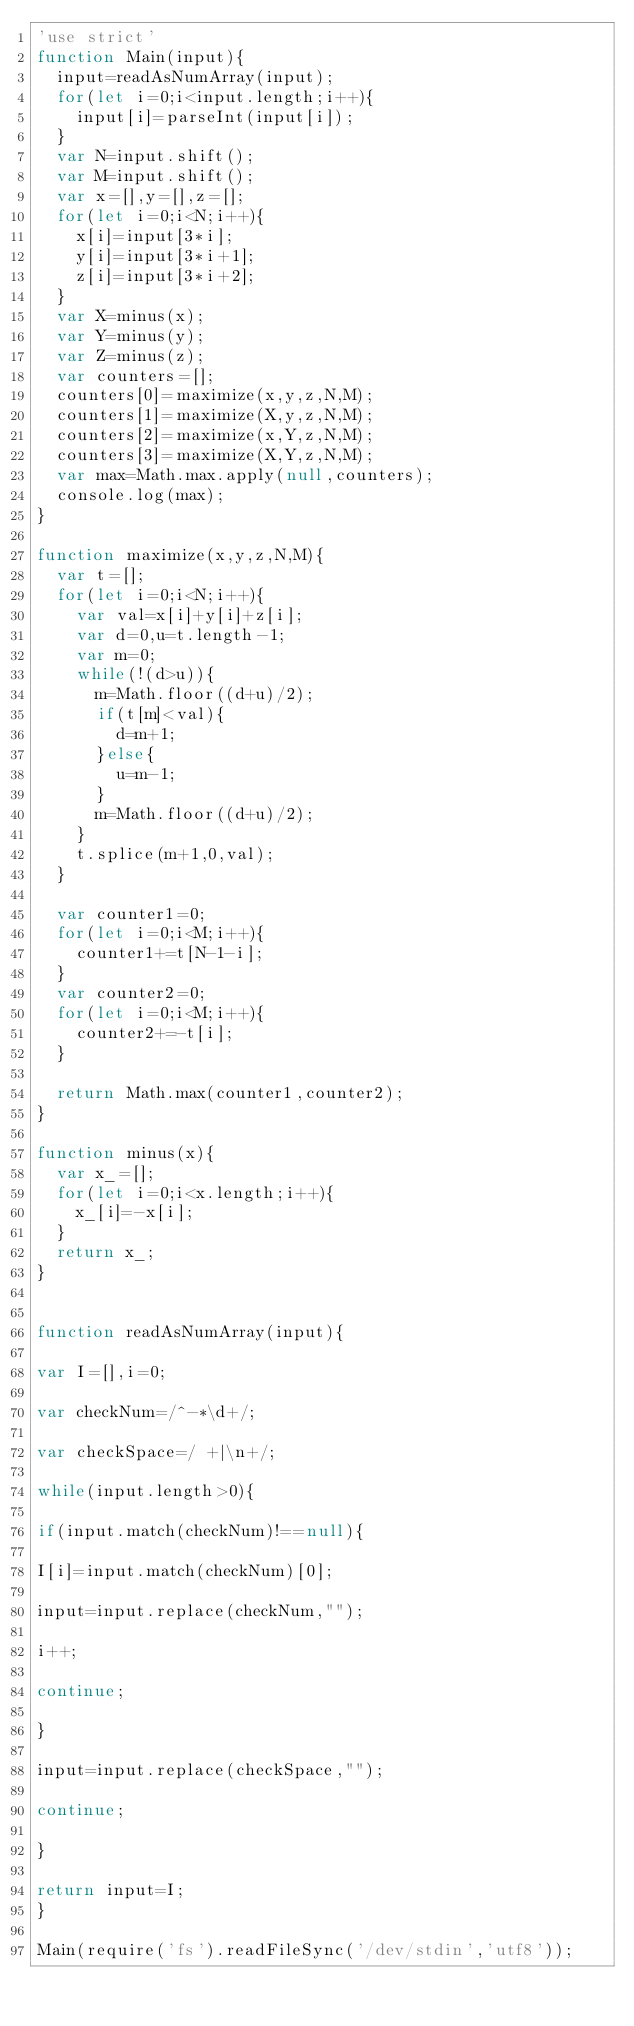<code> <loc_0><loc_0><loc_500><loc_500><_JavaScript_>'use strict'
function Main(input){
  input=readAsNumArray(input);
  for(let i=0;i<input.length;i++){
    input[i]=parseInt(input[i]);
  }
  var N=input.shift();
  var M=input.shift();
  var x=[],y=[],z=[];
  for(let i=0;i<N;i++){
    x[i]=input[3*i];
    y[i]=input[3*i+1];
    z[i]=input[3*i+2];
  }
  var X=minus(x);
  var Y=minus(y);
  var Z=minus(z);
  var counters=[];
  counters[0]=maximize(x,y,z,N,M);
  counters[1]=maximize(X,y,z,N,M);
  counters[2]=maximize(x,Y,z,N,M);
  counters[3]=maximize(X,Y,z,N,M);
  var max=Math.max.apply(null,counters);
  console.log(max);
} 

function maximize(x,y,z,N,M){
  var t=[];
  for(let i=0;i<N;i++){
    var val=x[i]+y[i]+z[i];
    var d=0,u=t.length-1;
    var m=0;
    while(!(d>u)){
      m=Math.floor((d+u)/2);
      if(t[m]<val){
        d=m+1;
      }else{
        u=m-1;
      }
      m=Math.floor((d+u)/2);
    }
    t.splice(m+1,0,val);
  }
  
  var counter1=0;
  for(let i=0;i<M;i++){
    counter1+=t[N-1-i];
  }
  var counter2=0;
  for(let i=0;i<M;i++){
    counter2+=-t[i];
  }
  
  return Math.max(counter1,counter2);
}

function minus(x){
  var x_=[];
  for(let i=0;i<x.length;i++){
    x_[i]=-x[i];
  }
  return x_;
}


function readAsNumArray(input){

var I=[],i=0;

var checkNum=/^-*\d+/;

var checkSpace=/ +|\n+/;

while(input.length>0){

if(input.match(checkNum)!==null){

I[i]=input.match(checkNum)[0];

input=input.replace(checkNum,""); 

i++;

continue;

}

input=input.replace(checkSpace,"");

continue;

}

return input=I;
}

Main(require('fs').readFileSync('/dev/stdin','utf8'));
</code> 